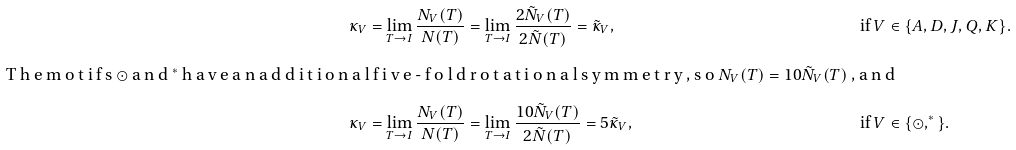<formula> <loc_0><loc_0><loc_500><loc_500>\kappa _ { V } & = \lim _ { T \to I } \frac { N _ { V } ( T ) } { N ( T ) } = \lim _ { T \to I } \frac { 2 \tilde { N } _ { V } ( T ) } { 2 \tilde { N } ( T ) } = \tilde { \kappa } _ { V } , & \text {if } V & \in \{ A , D , J , Q , K \} . \\ \intertext { T h e m o t i f s $ \odot $ a n d $ ^ { * } $ h a v e a n a d d i t i o n a l f i v e - f o l d r o t a t i o n a l s y m m e t r y , s o $ N _ { V } ( T ) = 1 0 \tilde { N } _ { V } ( T ) $ , a n d } \kappa _ { V } & = \lim _ { T \to I } \frac { N _ { V } ( T ) } { N ( T ) } = \lim _ { T \to I } \frac { 1 0 \tilde { N } _ { V } ( T ) } { 2 \tilde { N } ( T ) } = 5 \tilde { \kappa } _ { V } , & \text {if } V & \in \{ \odot , ^ { * } \} .</formula> 